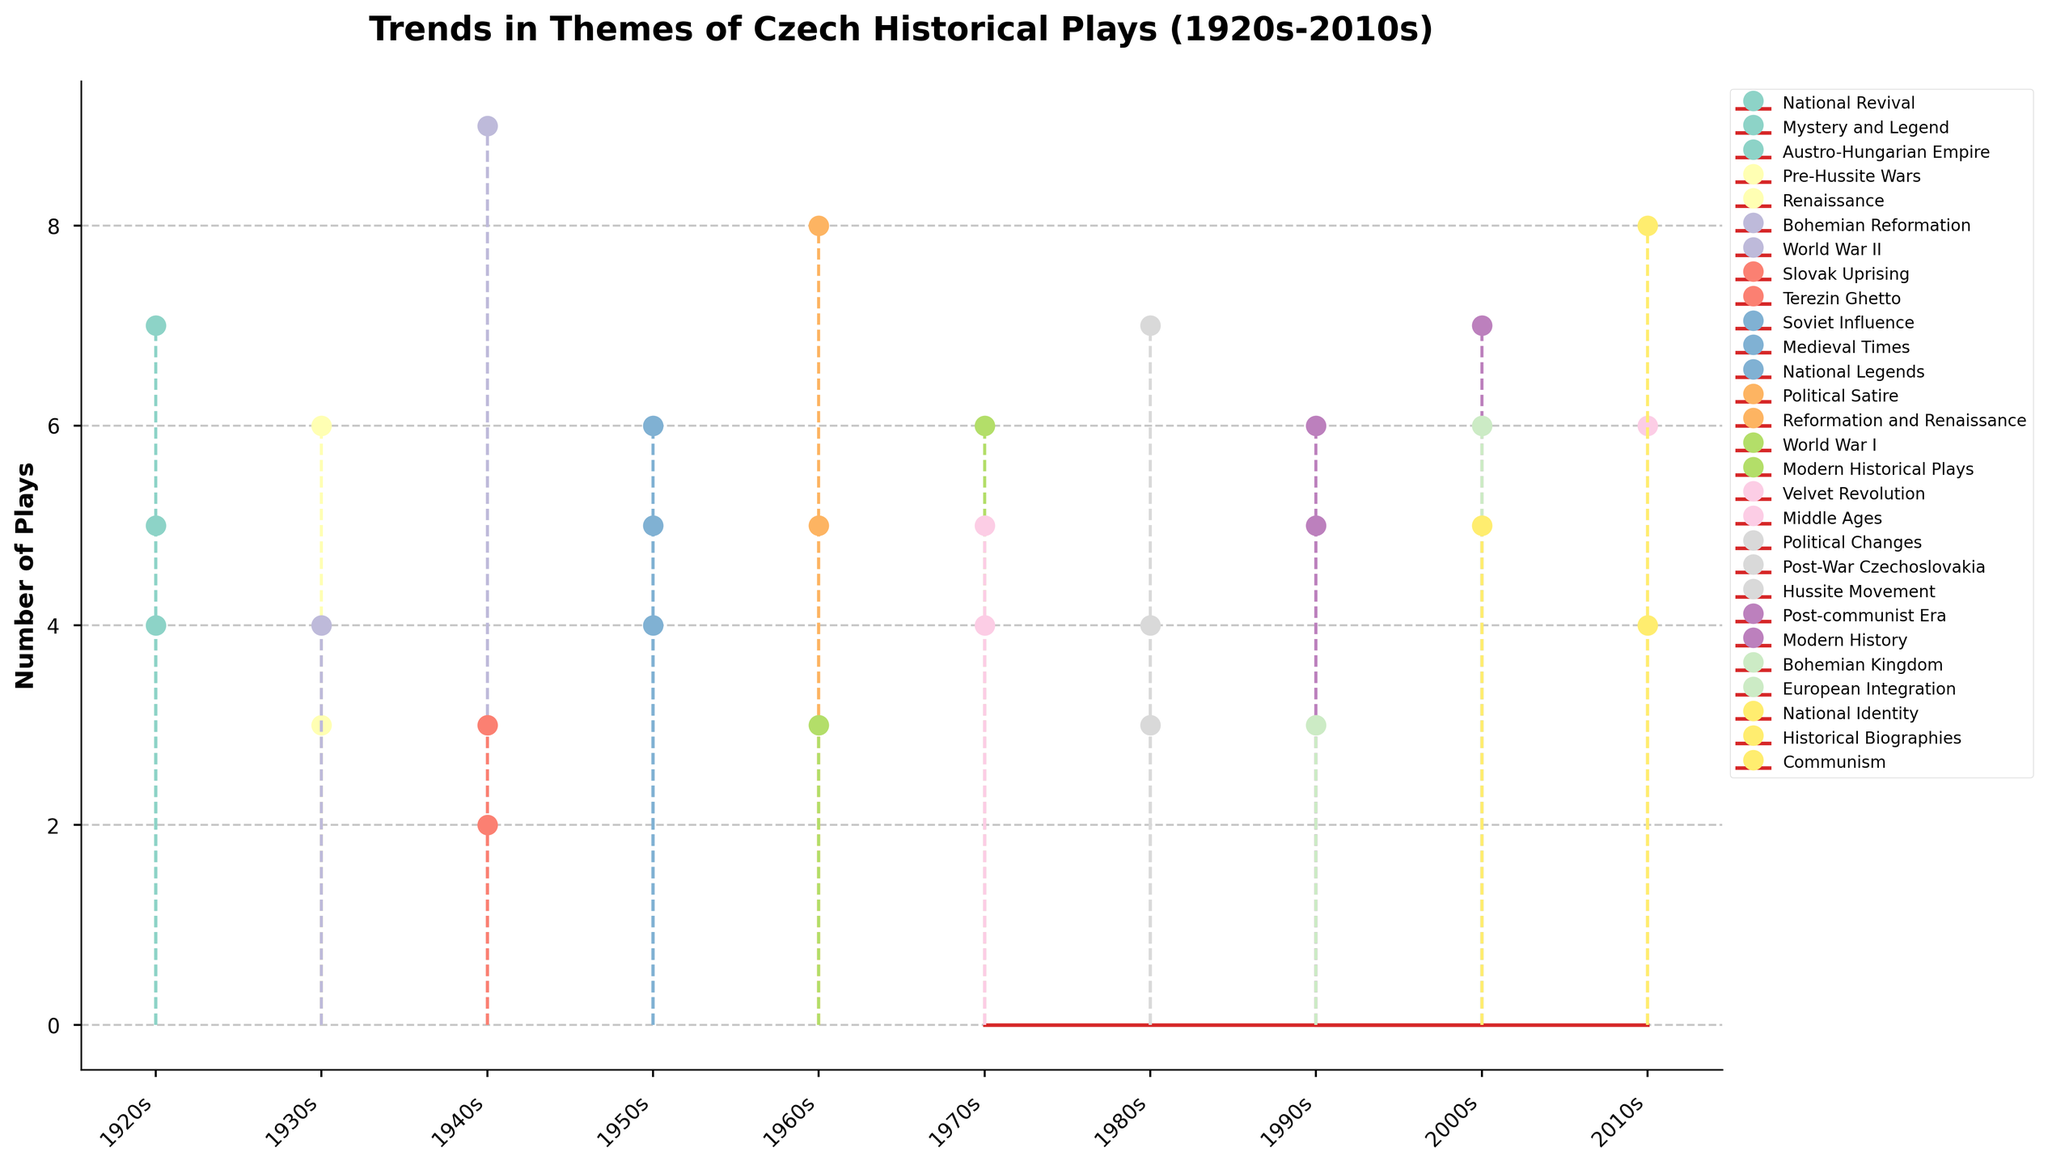What is the title of the figure? The title is usually located at the top of the figure. In this specific case, it should summarize the overall theme and timeline of the data visualized. The title is "Trends in Themes of Czech Historical Plays (1920s-2010s)."
Answer: Trends in Themes of Czech Historical Plays (1920s-2010s) Which theme has the most number of plays in the 1940s? By observing the markers corresponding to the themes in the 1940s, the tallest stemline among them represents the theme "World War II" with 9 plays.
Answer: World War II How many decades feature plays themed around the Velvet Revolution? Locate the markers representing the Velvet Revolution. These exist only in the 1970s and 2010s. Thus, there are two decades that feature this theme.
Answer: 2 What is the total number of plays for National Revival across all decades? Identify all instances of National Revival across all decades. The figure shows 7 plays in the 1920s, and no other decades include this theme. Adding these numbers gives a total of 7.
Answer: 7 Are there any themes present exclusively in one decade, and if so, which ones? Some themes appear only in one decade. By scanning all themes and their occurrences, "Austro-Hungarian Empire" in the 1920s is a theme represented exclusively in one decade.
Answer: Austro-Hungarian Empire, 1920s Which decade shows the highest number of plays related to modern historical topics? Themes such as Modern Historical Plays and Modern History are indicative of modern historical topics. Checking these themes across decades, the 2000s stand out with 7 plays for Modern History and 6 for European Integration, totaling 13 plays.
Answer: 2000s What is the difference in the number of plays between the medieval-themed plays of the 1950s and the 1970s? In the 1950s, Medieval Times has 6 plays. In the 1970s, Middle Ages has 5 plays. The difference is 6 - 5 = 1.
Answer: 1 Which theme related to political events appears in every decade from the 1940s to the 1980s? Political themes are examined. The theme "Political Satire" appears in the 1960s, and the theme "Political Changes" appears in the 1980s. However, no single political theme is present in every decade from the 1940s to the 1980s.
Answer: None How many plays themed around World War periods are there in total from the 1920s to the 1960s? Sum the plays related to World War I and II. World War II in the 1940s has 9 plays, World War I in the 1960s has 3 plays, totaling 9 + 3 = 12.
Answer: 12 Which historical event theme sees an increase in the number of plays from the 1970s to the 2010s? Compare the number of plays for themes from the 1970s to the 2010s. The Velvet Revolution shows an increase from 4 plays in the 1970s to 6 plays in the 2010s.
Answer: Velvet Revolution 